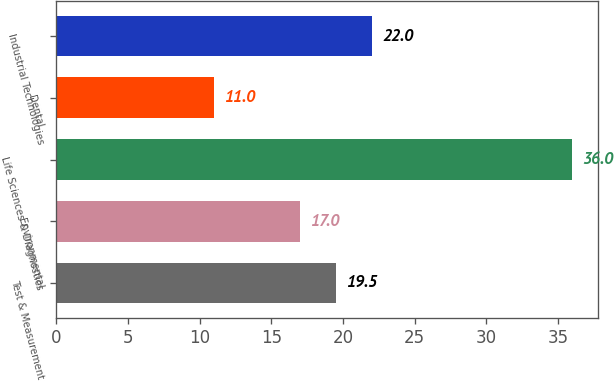<chart> <loc_0><loc_0><loc_500><loc_500><bar_chart><fcel>Test & Measurement<fcel>Environmental<fcel>Life Sciences & Diagnostics<fcel>Dental<fcel>Industrial Technologies<nl><fcel>19.5<fcel>17<fcel>36<fcel>11<fcel>22<nl></chart> 